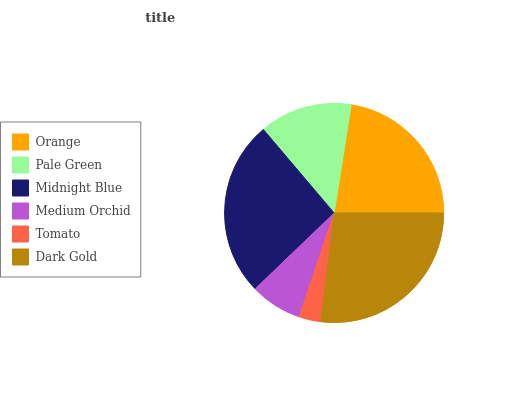Is Tomato the minimum?
Answer yes or no. Yes. Is Dark Gold the maximum?
Answer yes or no. Yes. Is Pale Green the minimum?
Answer yes or no. No. Is Pale Green the maximum?
Answer yes or no. No. Is Orange greater than Pale Green?
Answer yes or no. Yes. Is Pale Green less than Orange?
Answer yes or no. Yes. Is Pale Green greater than Orange?
Answer yes or no. No. Is Orange less than Pale Green?
Answer yes or no. No. Is Orange the high median?
Answer yes or no. Yes. Is Pale Green the low median?
Answer yes or no. Yes. Is Dark Gold the high median?
Answer yes or no. No. Is Orange the low median?
Answer yes or no. No. 